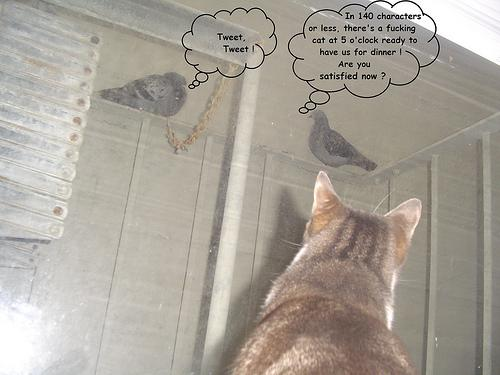Question: who has pointy ears?
Choices:
A. Cat.
B. Bunny.
C. Horse.
D. Dog.
Answer with the letter. Answer: A Question: what has feathers?
Choices:
A. Birds.
B. Hat.
C. Fan.
D. Shirt.
Answer with the letter. Answer: A Question: what has whiskers?
Choices:
A. Rabbit.
B. The cat.
C. Mouse.
D. Seal.
Answer with the letter. Answer: B Question: what is gray?
Choices:
A. Dog.
B. Rabbit.
C. Mouse.
D. A cat.
Answer with the letter. Answer: D Question: how many birds are there?
Choices:
A. Three.
B. Two.
C. Four.
D. Five.
Answer with the letter. Answer: B Question: what color are birds?
Choices:
A. Brown.
B. Black.
C. Gray.
D. Yellow.
Answer with the letter. Answer: B 